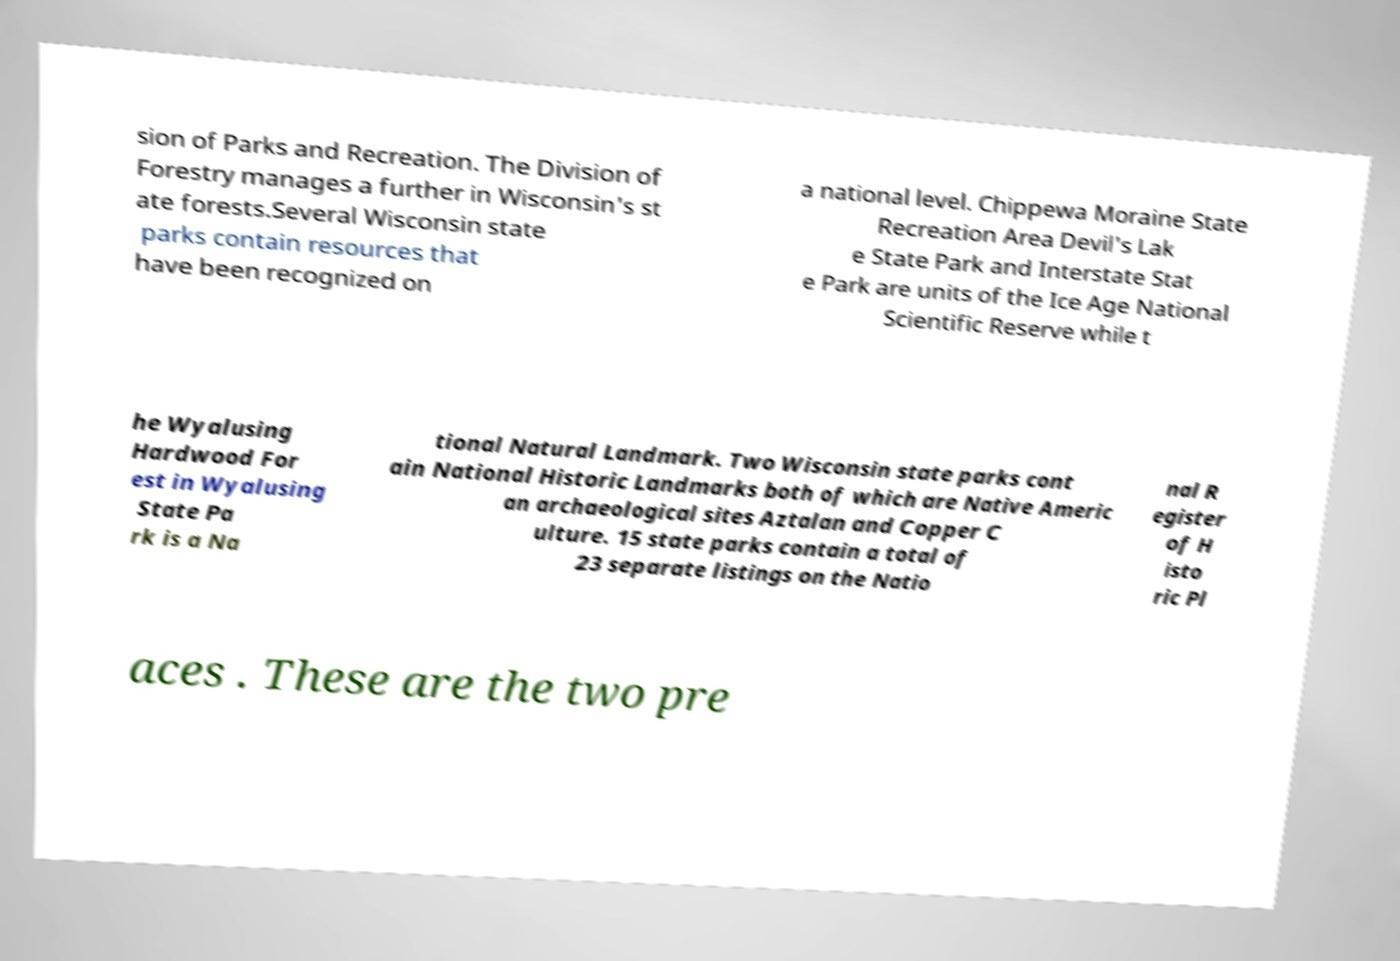Could you assist in decoding the text presented in this image and type it out clearly? sion of Parks and Recreation. The Division of Forestry manages a further in Wisconsin's st ate forests.Several Wisconsin state parks contain resources that have been recognized on a national level. Chippewa Moraine State Recreation Area Devil's Lak e State Park and Interstate Stat e Park are units of the Ice Age National Scientific Reserve while t he Wyalusing Hardwood For est in Wyalusing State Pa rk is a Na tional Natural Landmark. Two Wisconsin state parks cont ain National Historic Landmarks both of which are Native Americ an archaeological sites Aztalan and Copper C ulture. 15 state parks contain a total of 23 separate listings on the Natio nal R egister of H isto ric Pl aces . These are the two pre 